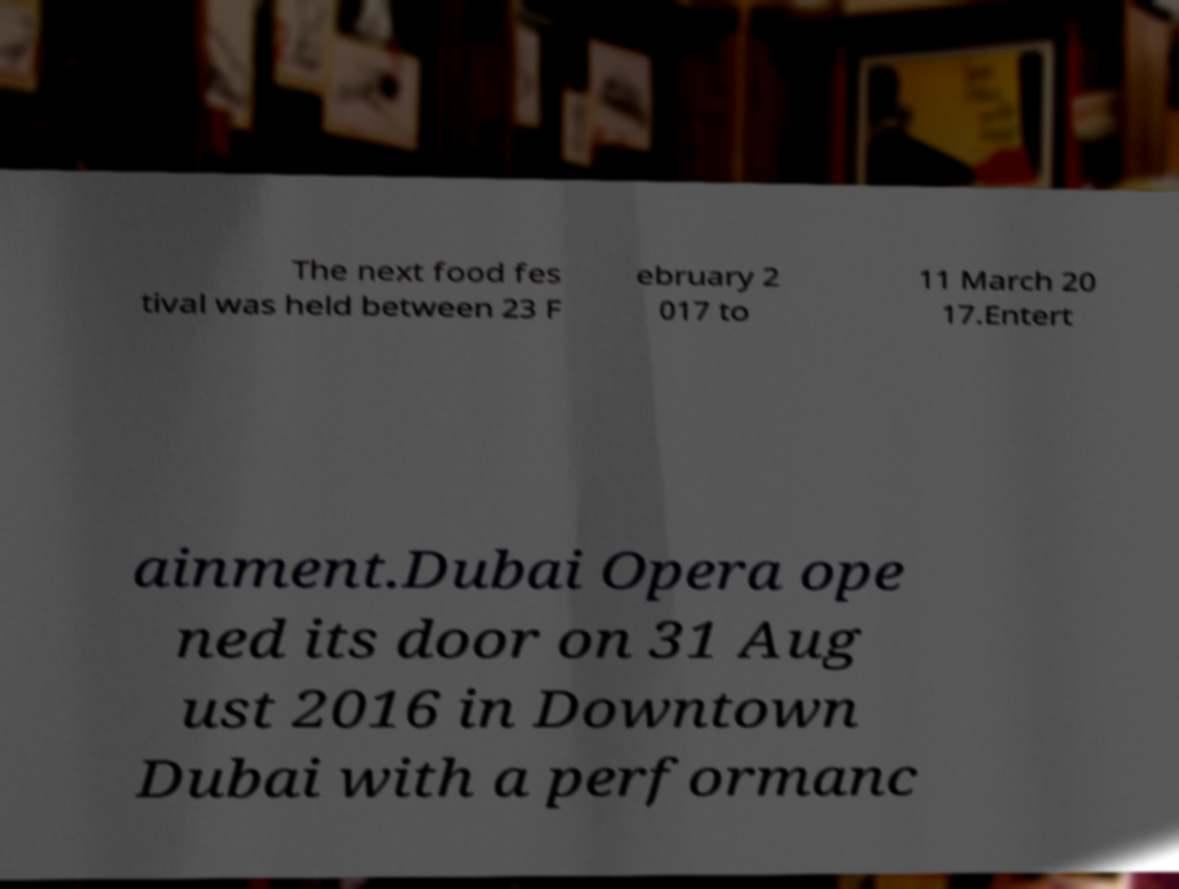Can you accurately transcribe the text from the provided image for me? The next food fes tival was held between 23 F ebruary 2 017 to 11 March 20 17.Entert ainment.Dubai Opera ope ned its door on 31 Aug ust 2016 in Downtown Dubai with a performanc 